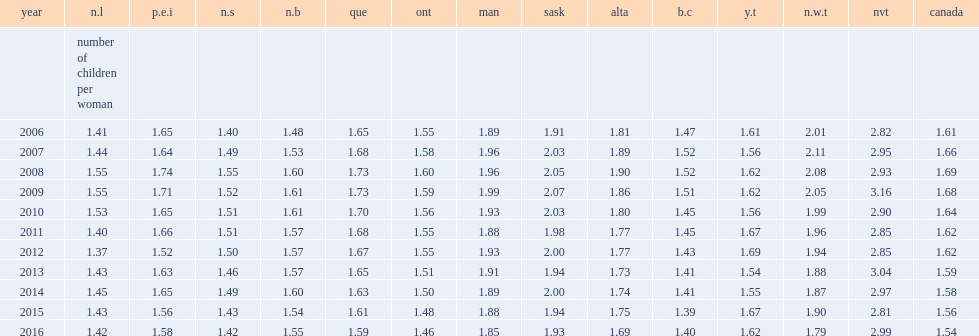How is the total fertility rate of nunavut between 2006 and 2016 represented by children per woman? 2.933636. How is the total fertility rate of nunavut in 2012 represented by children per woman? 2.85. How is the total fertility rate of nunavut in 2016 represented by children per woman? 2.99. Which territory has lower total fertility rate in 2012, in newfoundland and labrador or in total canada? N.l. Which territory has lower total fertility rate in 2016, in newfoundland and labrador or in total canada? N.l. Which territory has lower total fertility rate in 2012, in british columbia or in total canada? B.c. Which territory has lower total fertility rate in 2016, in british columbia or in total canada? B.c. Which territory has lower total fertility rate in 2012, in ontario or in total canada? Ont. Which territory has lower total fertility rate in 2016, in ontario or in total canada? Ont. 